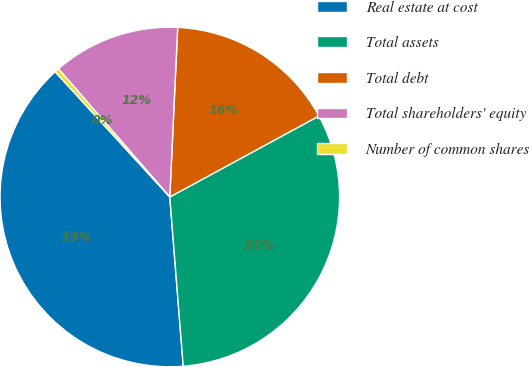<chart> <loc_0><loc_0><loc_500><loc_500><pie_chart><fcel>Real estate at cost<fcel>Total assets<fcel>Total debt<fcel>Total shareholders' equity<fcel>Number of common shares<nl><fcel>39.46%<fcel>31.66%<fcel>16.34%<fcel>12.12%<fcel>0.42%<nl></chart> 